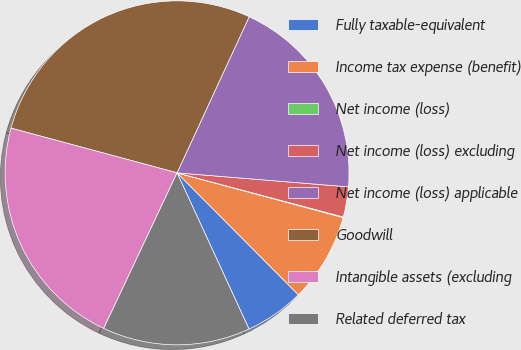<chart> <loc_0><loc_0><loc_500><loc_500><pie_chart><fcel>Fully taxable-equivalent<fcel>Income tax expense (benefit)<fcel>Net income (loss)<fcel>Net income (loss) excluding<fcel>Net income (loss) applicable<fcel>Goodwill<fcel>Intangible assets (excluding<fcel>Related deferred tax<nl><fcel>5.59%<fcel>8.35%<fcel>0.06%<fcel>2.83%<fcel>19.41%<fcel>27.7%<fcel>22.17%<fcel>13.88%<nl></chart> 